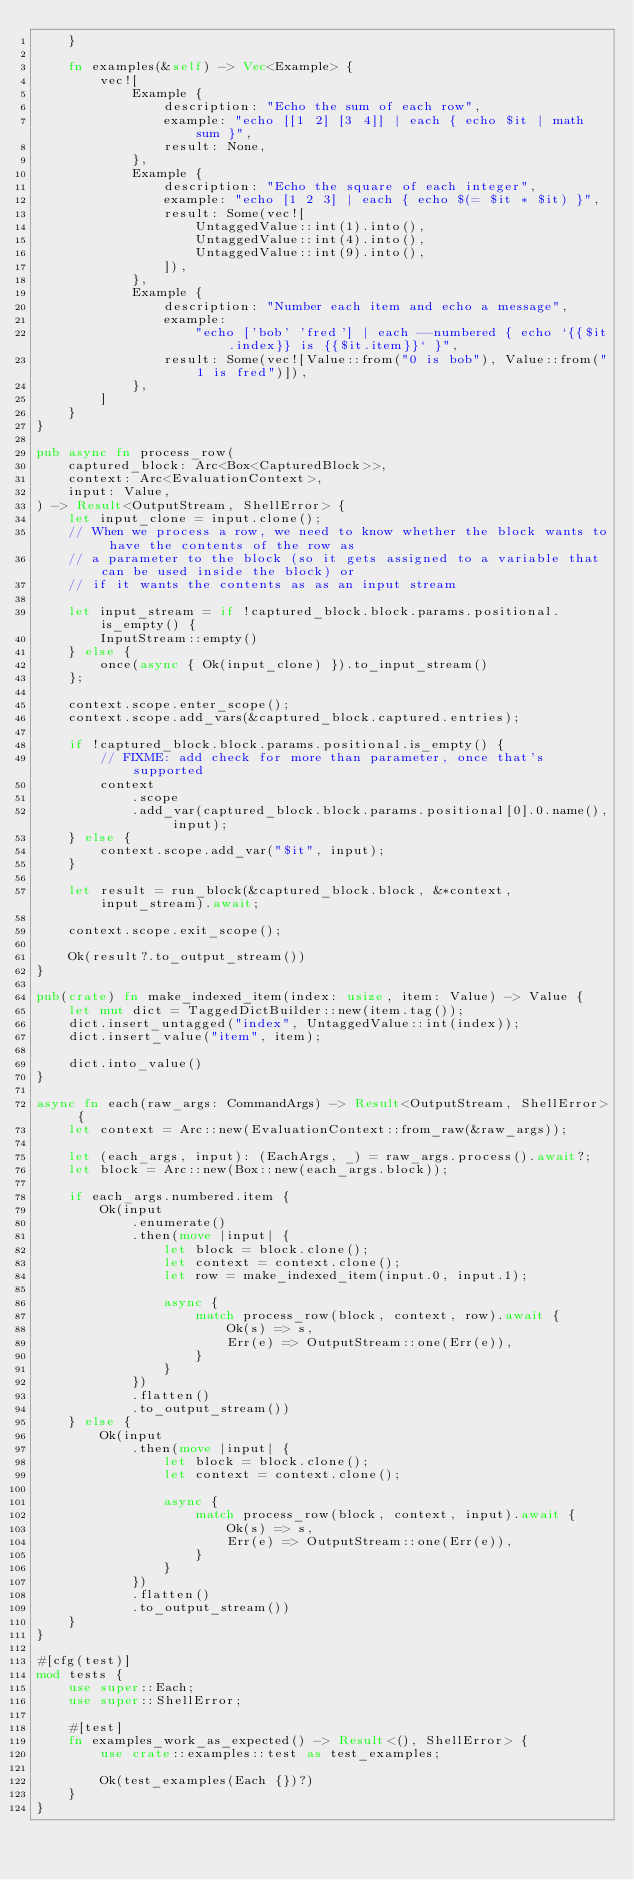<code> <loc_0><loc_0><loc_500><loc_500><_Rust_>    }

    fn examples(&self) -> Vec<Example> {
        vec![
            Example {
                description: "Echo the sum of each row",
                example: "echo [[1 2] [3 4]] | each { echo $it | math sum }",
                result: None,
            },
            Example {
                description: "Echo the square of each integer",
                example: "echo [1 2 3] | each { echo $(= $it * $it) }",
                result: Some(vec![
                    UntaggedValue::int(1).into(),
                    UntaggedValue::int(4).into(),
                    UntaggedValue::int(9).into(),
                ]),
            },
            Example {
                description: "Number each item and echo a message",
                example:
                    "echo ['bob' 'fred'] | each --numbered { echo `{{$it.index}} is {{$it.item}}` }",
                result: Some(vec![Value::from("0 is bob"), Value::from("1 is fred")]),
            },
        ]
    }
}

pub async fn process_row(
    captured_block: Arc<Box<CapturedBlock>>,
    context: Arc<EvaluationContext>,
    input: Value,
) -> Result<OutputStream, ShellError> {
    let input_clone = input.clone();
    // When we process a row, we need to know whether the block wants to have the contents of the row as
    // a parameter to the block (so it gets assigned to a variable that can be used inside the block) or
    // if it wants the contents as as an input stream

    let input_stream = if !captured_block.block.params.positional.is_empty() {
        InputStream::empty()
    } else {
        once(async { Ok(input_clone) }).to_input_stream()
    };

    context.scope.enter_scope();
    context.scope.add_vars(&captured_block.captured.entries);

    if !captured_block.block.params.positional.is_empty() {
        // FIXME: add check for more than parameter, once that's supported
        context
            .scope
            .add_var(captured_block.block.params.positional[0].0.name(), input);
    } else {
        context.scope.add_var("$it", input);
    }

    let result = run_block(&captured_block.block, &*context, input_stream).await;

    context.scope.exit_scope();

    Ok(result?.to_output_stream())
}

pub(crate) fn make_indexed_item(index: usize, item: Value) -> Value {
    let mut dict = TaggedDictBuilder::new(item.tag());
    dict.insert_untagged("index", UntaggedValue::int(index));
    dict.insert_value("item", item);

    dict.into_value()
}

async fn each(raw_args: CommandArgs) -> Result<OutputStream, ShellError> {
    let context = Arc::new(EvaluationContext::from_raw(&raw_args));

    let (each_args, input): (EachArgs, _) = raw_args.process().await?;
    let block = Arc::new(Box::new(each_args.block));

    if each_args.numbered.item {
        Ok(input
            .enumerate()
            .then(move |input| {
                let block = block.clone();
                let context = context.clone();
                let row = make_indexed_item(input.0, input.1);

                async {
                    match process_row(block, context, row).await {
                        Ok(s) => s,
                        Err(e) => OutputStream::one(Err(e)),
                    }
                }
            })
            .flatten()
            .to_output_stream())
    } else {
        Ok(input
            .then(move |input| {
                let block = block.clone();
                let context = context.clone();

                async {
                    match process_row(block, context, input).await {
                        Ok(s) => s,
                        Err(e) => OutputStream::one(Err(e)),
                    }
                }
            })
            .flatten()
            .to_output_stream())
    }
}

#[cfg(test)]
mod tests {
    use super::Each;
    use super::ShellError;

    #[test]
    fn examples_work_as_expected() -> Result<(), ShellError> {
        use crate::examples::test as test_examples;

        Ok(test_examples(Each {})?)
    }
}
</code> 